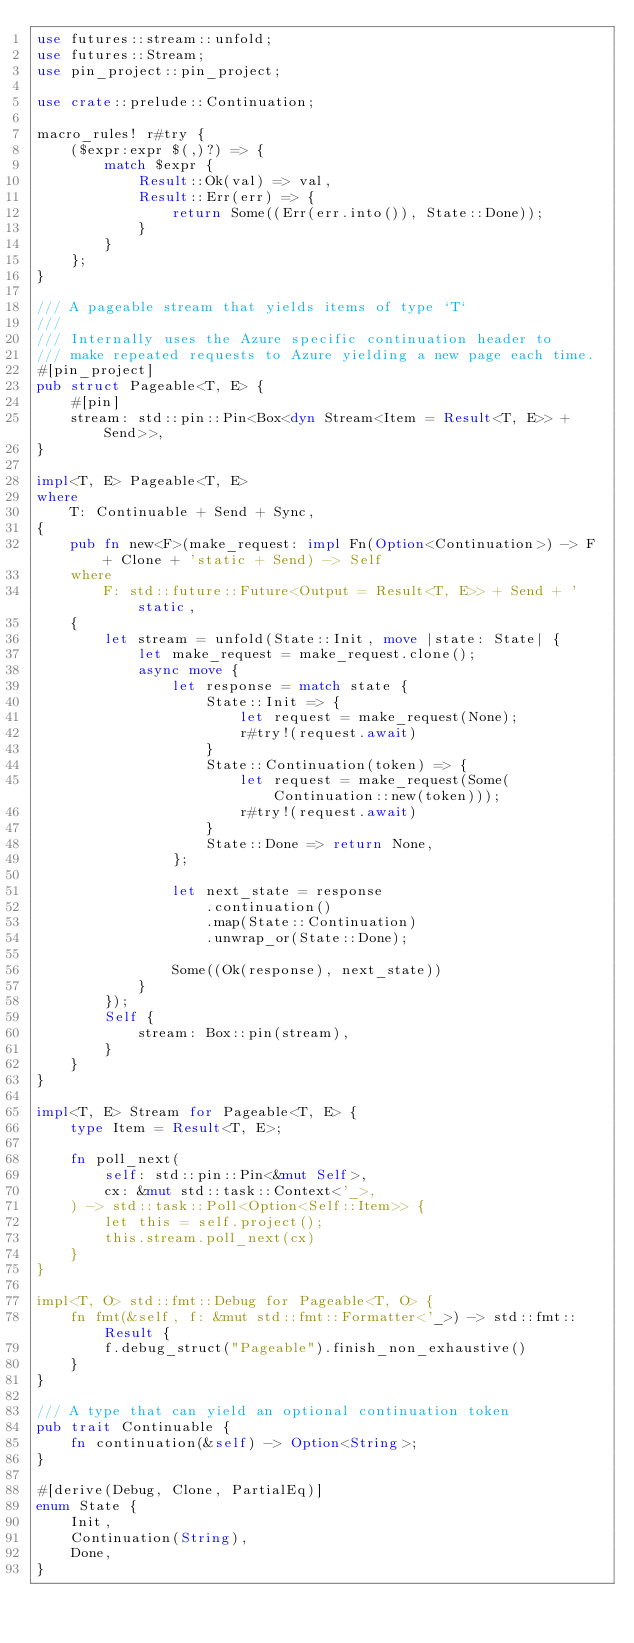<code> <loc_0><loc_0><loc_500><loc_500><_Rust_>use futures::stream::unfold;
use futures::Stream;
use pin_project::pin_project;

use crate::prelude::Continuation;

macro_rules! r#try {
    ($expr:expr $(,)?) => {
        match $expr {
            Result::Ok(val) => val,
            Result::Err(err) => {
                return Some((Err(err.into()), State::Done));
            }
        }
    };
}

/// A pageable stream that yields items of type `T`
///
/// Internally uses the Azure specific continuation header to
/// make repeated requests to Azure yielding a new page each time.
#[pin_project]
pub struct Pageable<T, E> {
    #[pin]
    stream: std::pin::Pin<Box<dyn Stream<Item = Result<T, E>> + Send>>,
}

impl<T, E> Pageable<T, E>
where
    T: Continuable + Send + Sync,
{
    pub fn new<F>(make_request: impl Fn(Option<Continuation>) -> F + Clone + 'static + Send) -> Self
    where
        F: std::future::Future<Output = Result<T, E>> + Send + 'static,
    {
        let stream = unfold(State::Init, move |state: State| {
            let make_request = make_request.clone();
            async move {
                let response = match state {
                    State::Init => {
                        let request = make_request(None);
                        r#try!(request.await)
                    }
                    State::Continuation(token) => {
                        let request = make_request(Some(Continuation::new(token)));
                        r#try!(request.await)
                    }
                    State::Done => return None,
                };

                let next_state = response
                    .continuation()
                    .map(State::Continuation)
                    .unwrap_or(State::Done);

                Some((Ok(response), next_state))
            }
        });
        Self {
            stream: Box::pin(stream),
        }
    }
}

impl<T, E> Stream for Pageable<T, E> {
    type Item = Result<T, E>;

    fn poll_next(
        self: std::pin::Pin<&mut Self>,
        cx: &mut std::task::Context<'_>,
    ) -> std::task::Poll<Option<Self::Item>> {
        let this = self.project();
        this.stream.poll_next(cx)
    }
}

impl<T, O> std::fmt::Debug for Pageable<T, O> {
    fn fmt(&self, f: &mut std::fmt::Formatter<'_>) -> std::fmt::Result {
        f.debug_struct("Pageable").finish_non_exhaustive()
    }
}

/// A type that can yield an optional continuation token
pub trait Continuable {
    fn continuation(&self) -> Option<String>;
}

#[derive(Debug, Clone, PartialEq)]
enum State {
    Init,
    Continuation(String),
    Done,
}
</code> 